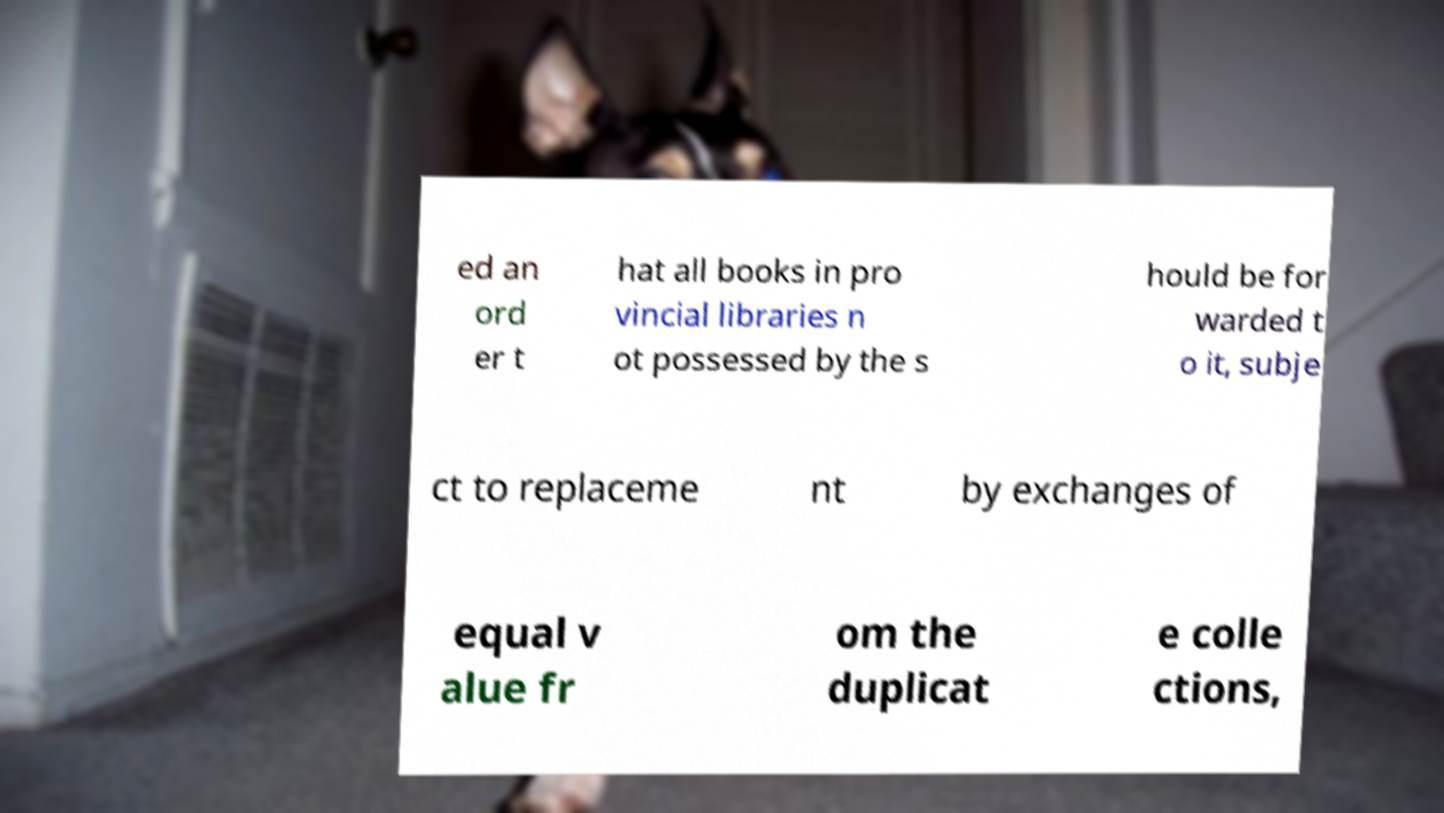For documentation purposes, I need the text within this image transcribed. Could you provide that? ed an ord er t hat all books in pro vincial libraries n ot possessed by the s hould be for warded t o it, subje ct to replaceme nt by exchanges of equal v alue fr om the duplicat e colle ctions, 